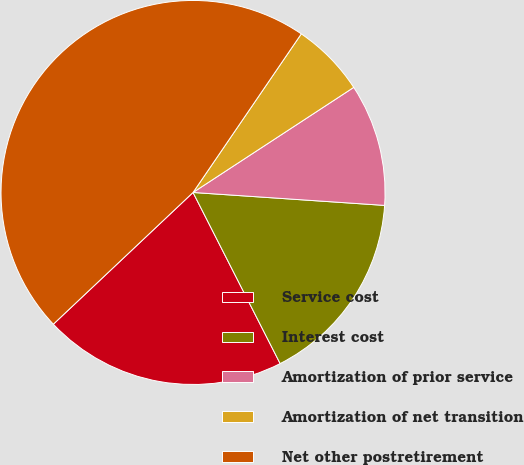Convert chart. <chart><loc_0><loc_0><loc_500><loc_500><pie_chart><fcel>Service cost<fcel>Interest cost<fcel>Amortization of prior service<fcel>Amortization of net transition<fcel>Net other postretirement<nl><fcel>20.46%<fcel>16.43%<fcel>10.29%<fcel>6.25%<fcel>46.56%<nl></chart> 